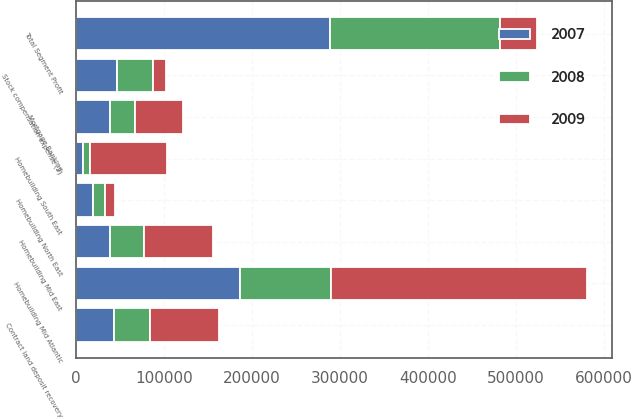Convert chart. <chart><loc_0><loc_0><loc_500><loc_500><stacked_bar_chart><ecel><fcel>Homebuilding Mid Atlantic<fcel>Homebuilding North East<fcel>Homebuilding Mid East<fcel>Homebuilding South East<fcel>Mortgage Banking<fcel>Total Segment Profit<fcel>Contract land deposit recovery<fcel>Stock compensation expense (2)<nl><fcel>2007<fcel>185861<fcel>19572<fcel>38012<fcel>7384<fcel>38138<fcel>288967<fcel>42939<fcel>46302<nl><fcel>2008<fcel>103690<fcel>13182<fcel>39643<fcel>7904<fcel>29227<fcel>193646<fcel>41134<fcel>41204<nl><fcel>2009<fcel>291012<fcel>11176<fcel>78547<fcel>87701<fcel>54576<fcel>41204<fcel>79002<fcel>14189<nl></chart> 